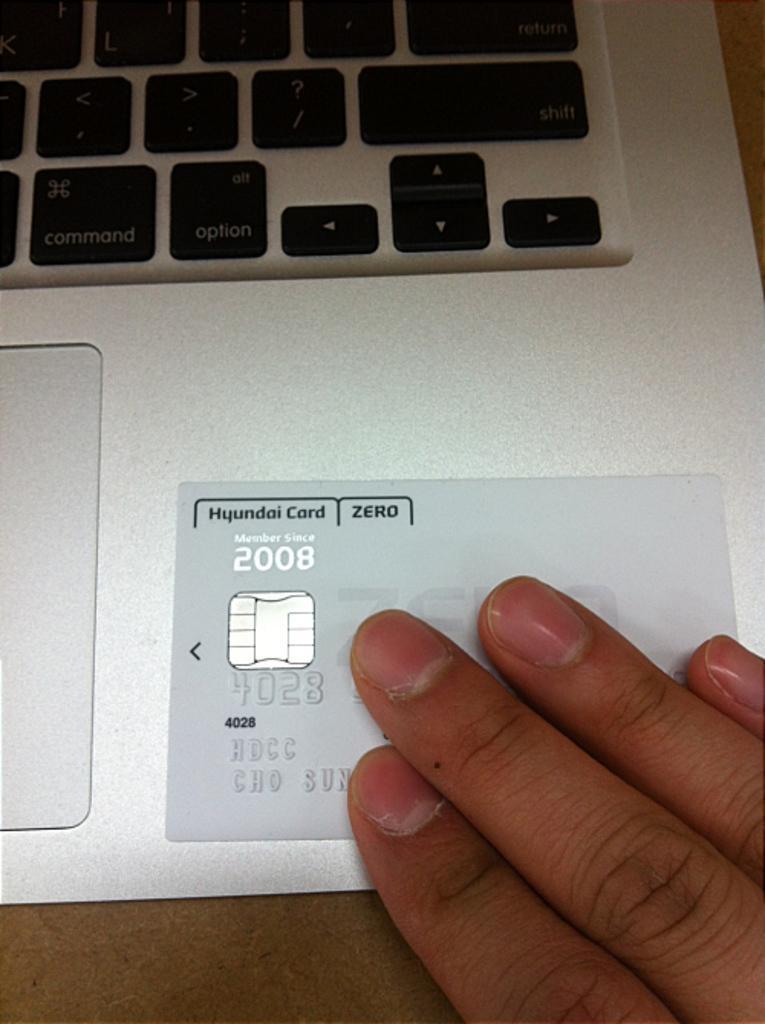In one or two sentences, can you explain what this image depicts? In this image I can see the laptop on the brown color table. On the laptop I can see the person's hand. 